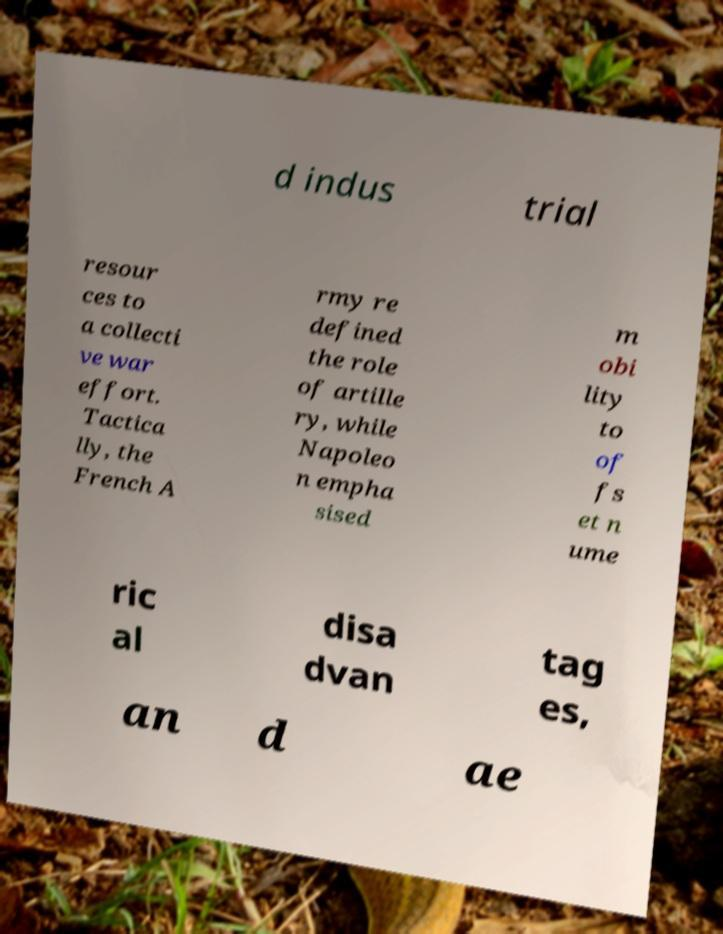I need the written content from this picture converted into text. Can you do that? d indus trial resour ces to a collecti ve war effort. Tactica lly, the French A rmy re defined the role of artille ry, while Napoleo n empha sised m obi lity to of fs et n ume ric al disa dvan tag es, an d ae 